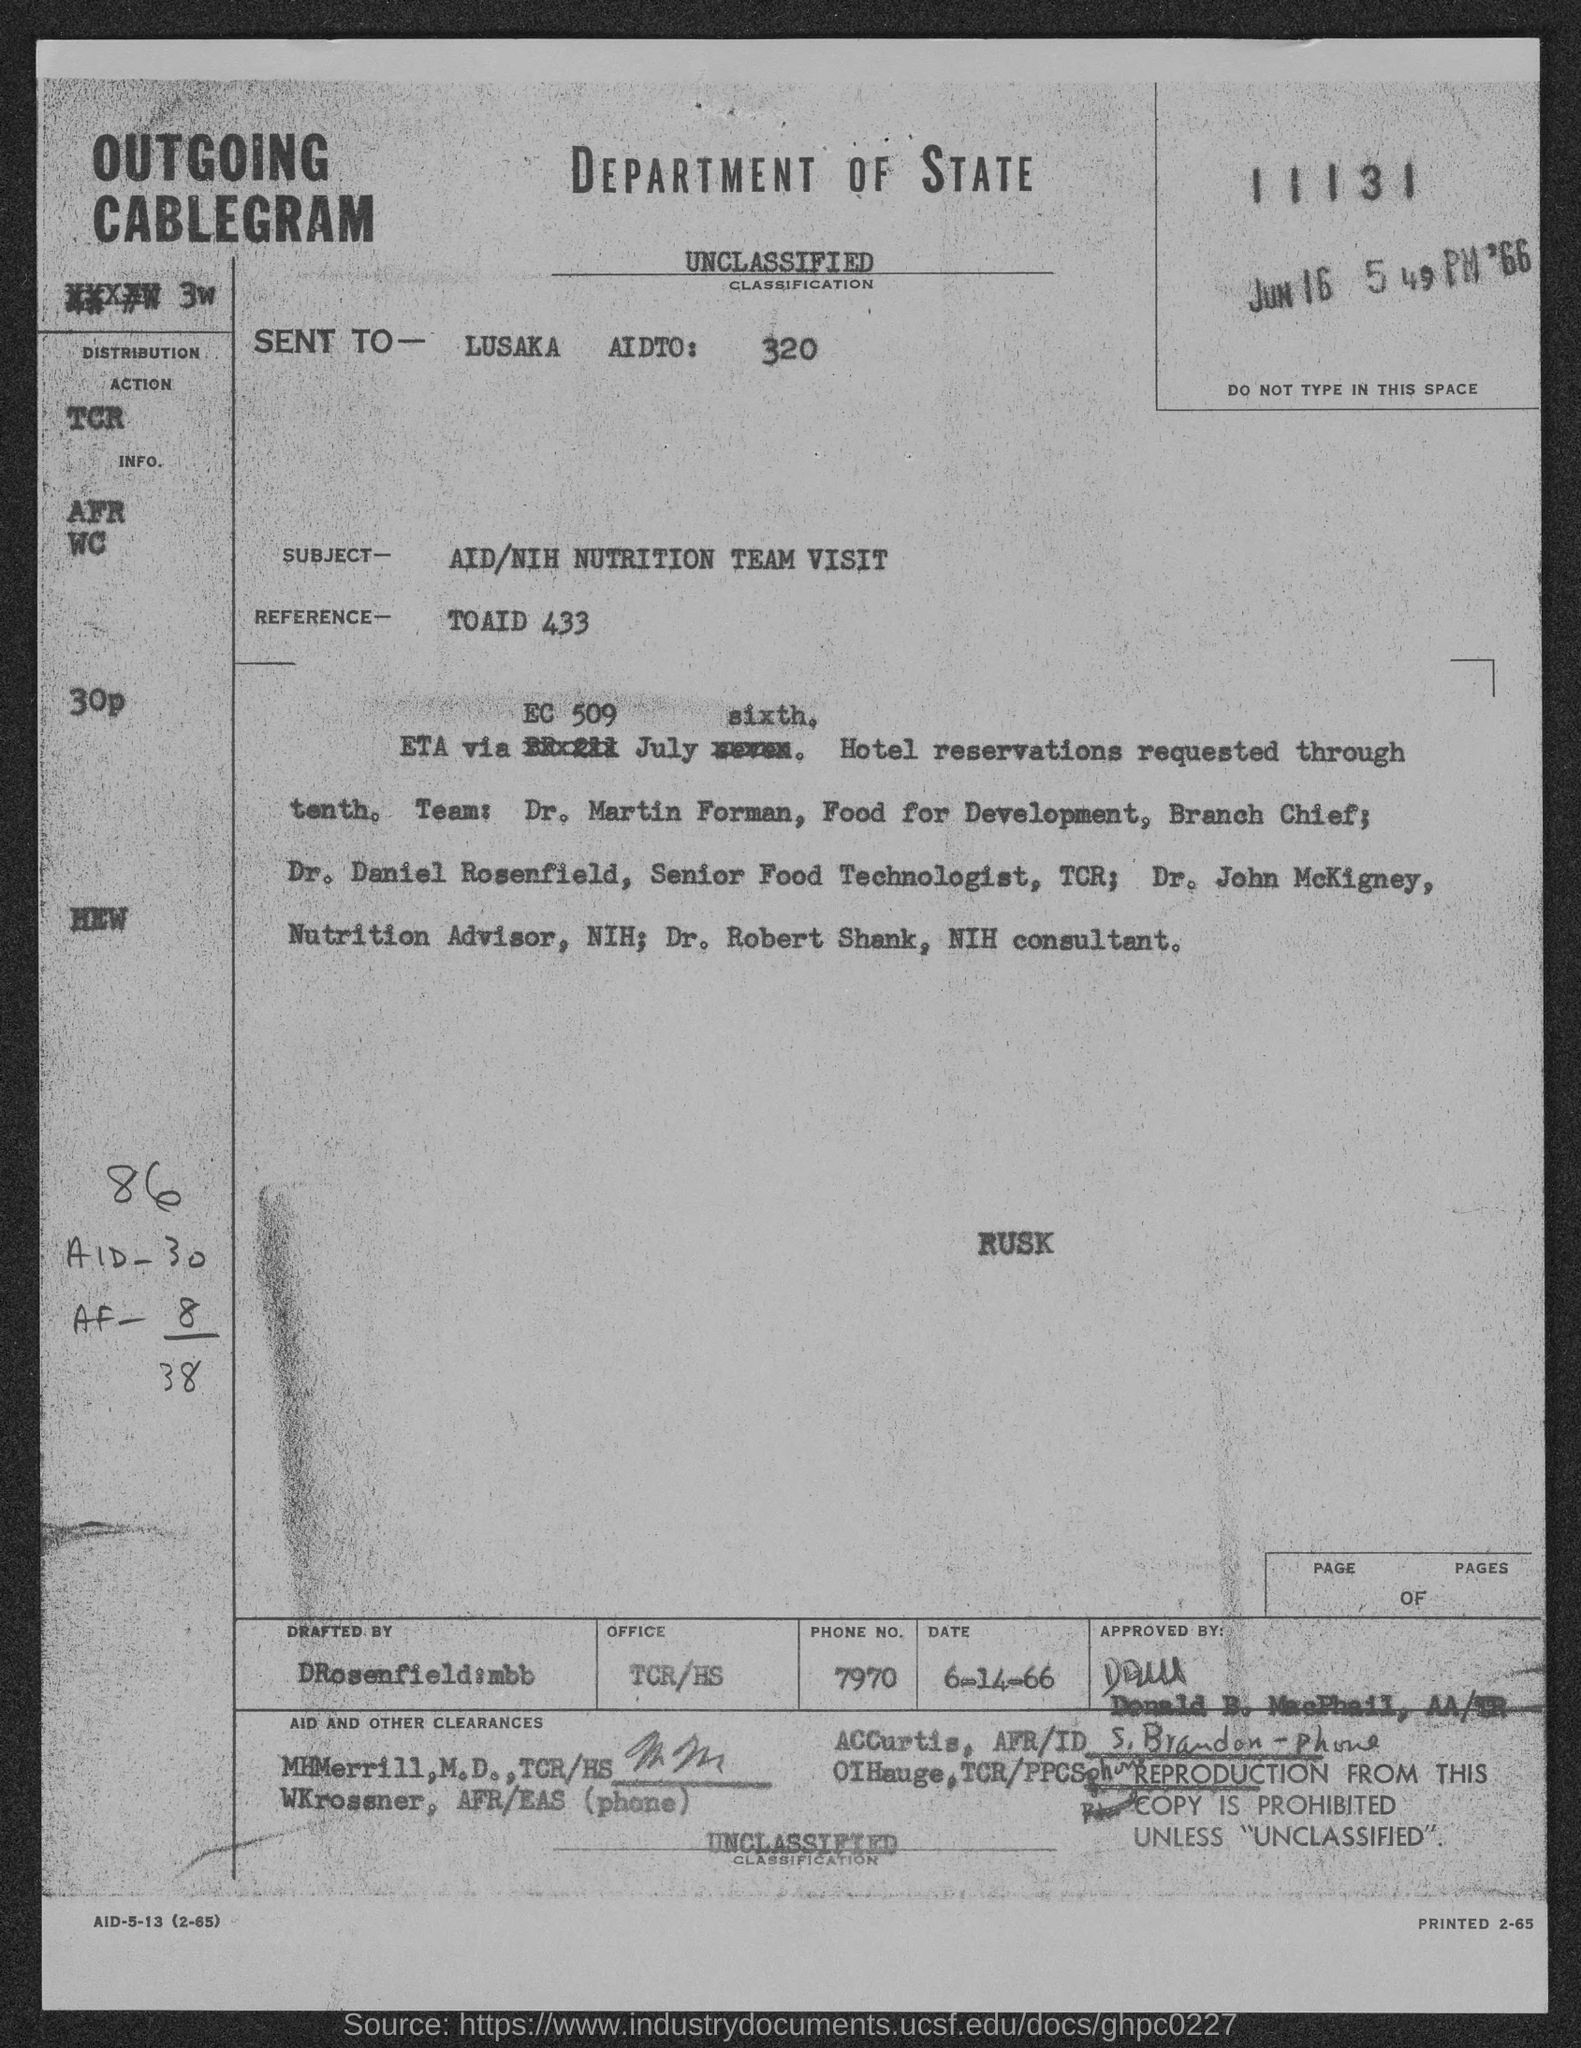What is the classification?
Your answer should be compact. Unclassified. Who is it sent to?
Ensure brevity in your answer.  Lusaka Aidto: 320. What is the subject?
Your answer should be compact. AID/NIH Nutrition Team Visit. What is the reference?
Offer a very short reply. TOAID 433. 